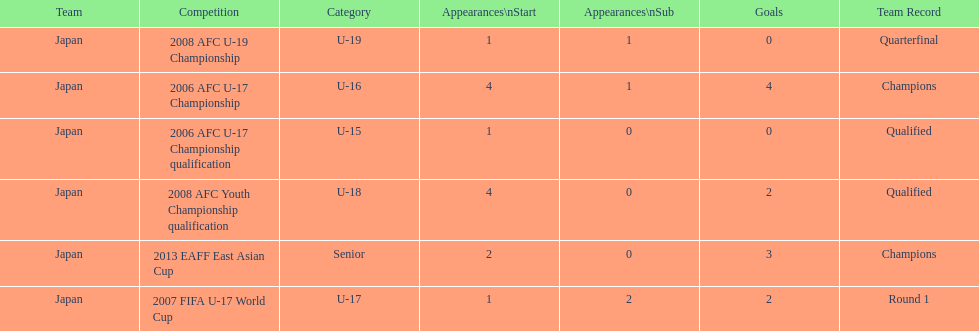Name the earliest competition to have a sub. 2006 AFC U-17 Championship. 